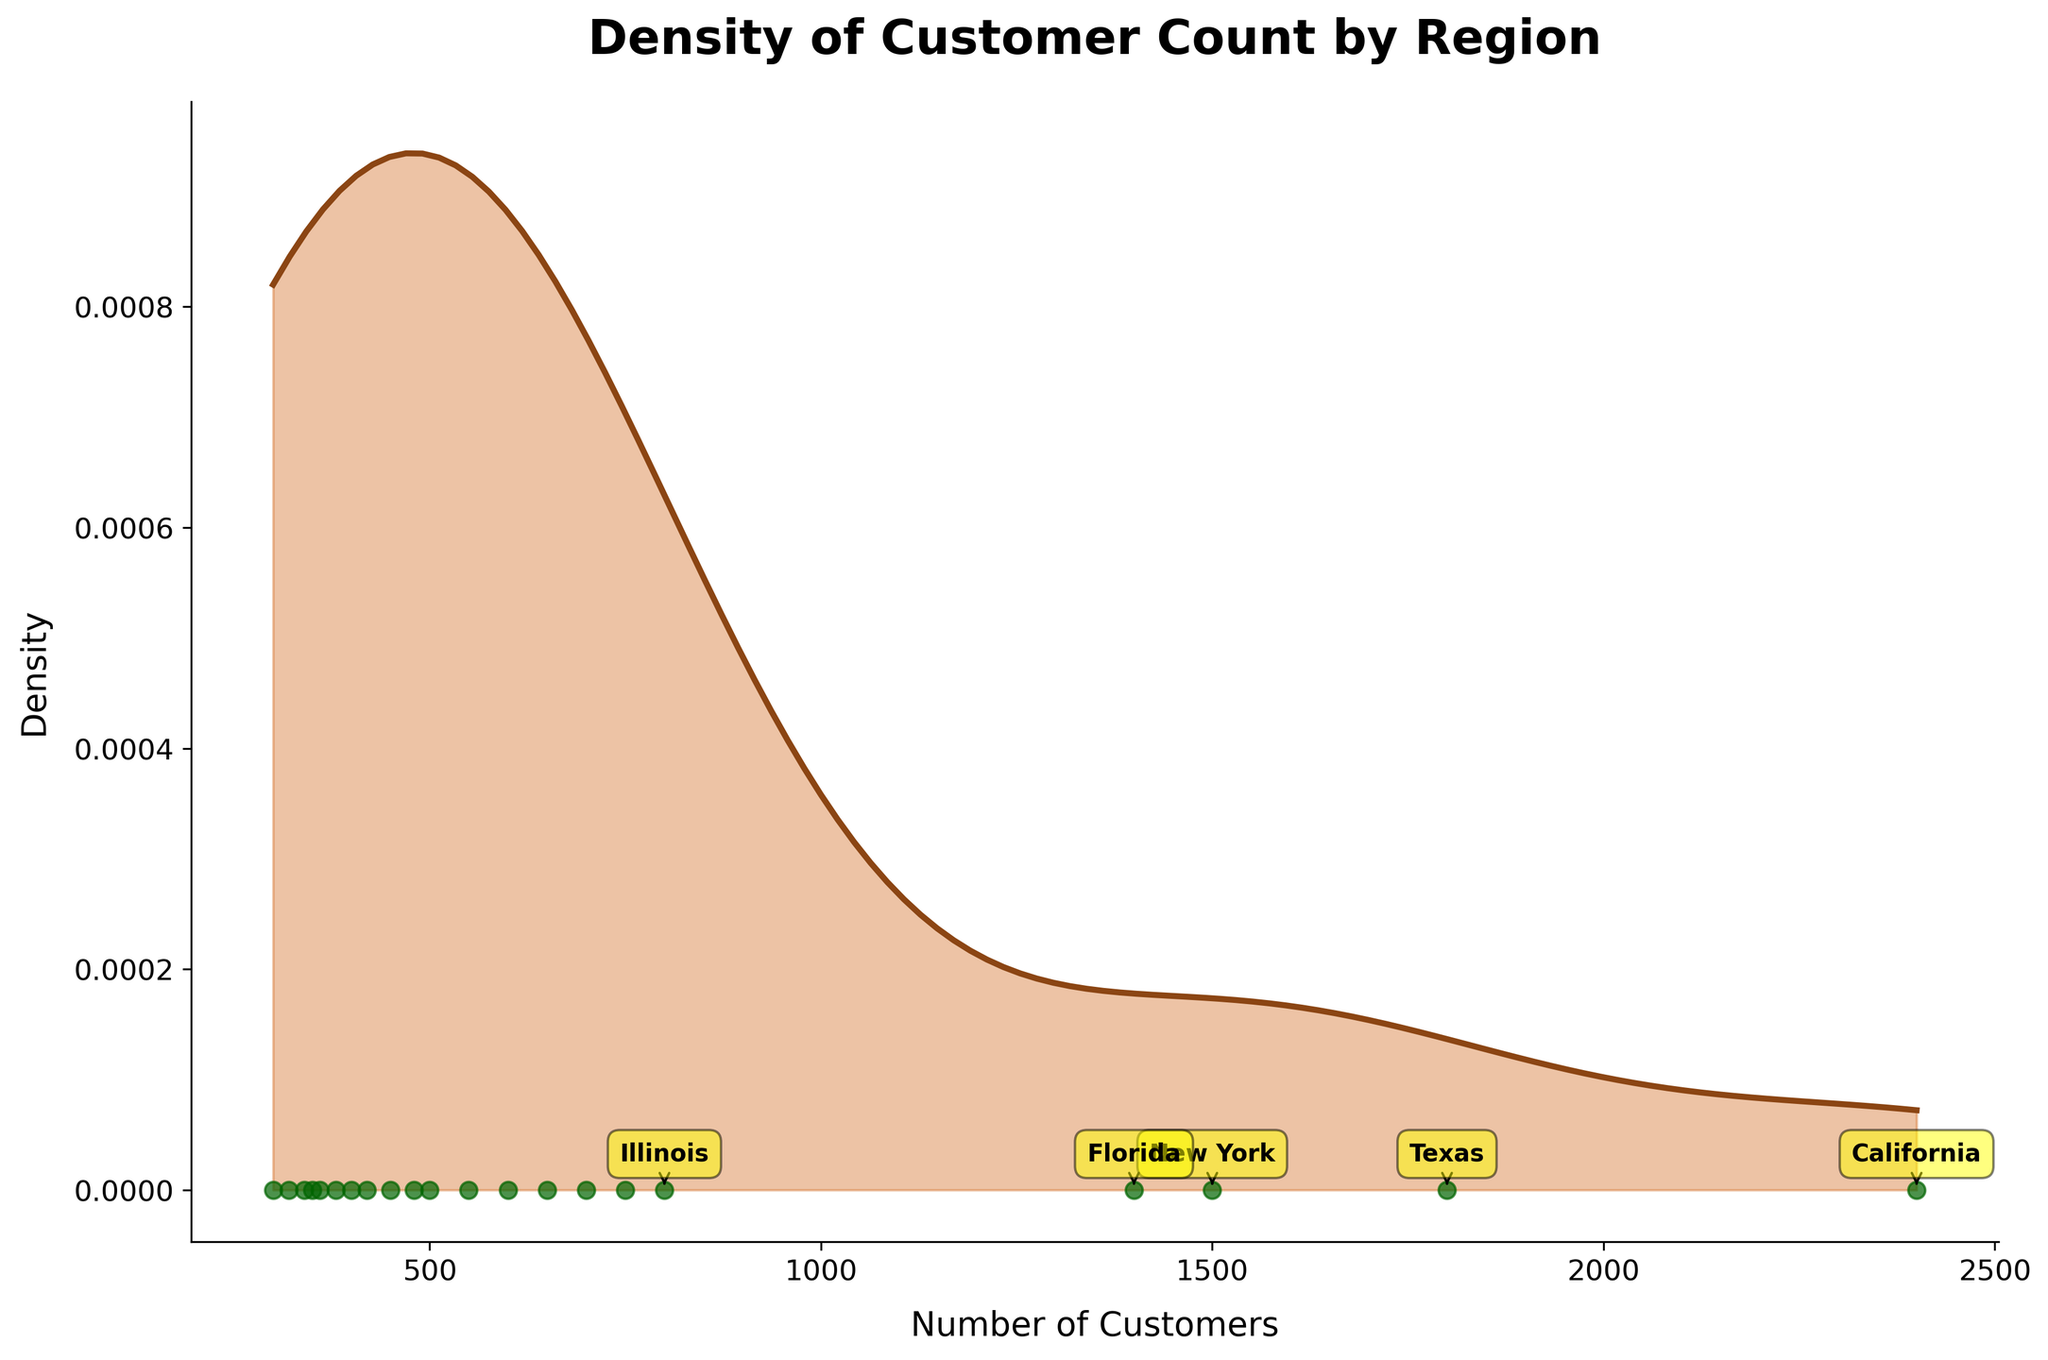What is the title of the figure? The title of the figure is visually the largest text, usually located at the top of the plot. In this figure, it reads "Density of Customer Count by Region."
Answer: Density of Customer Count by Region What color is used for the density line in the plot? The density line is represented using a continuous and prominently visible color to stand out. In this plot, it is drawn using a brownish color.
Answer: Brown Which region has the highest customer count? Looking at the annotations for the top 5 regions, the highest customer count is marked at the highest scatter point on the x-axis. The annotation for the highest peak is for the region "California."
Answer: California How many regions have been annotated in the figure? There are several written annotations pointing to specific points along the x-axis. By counting the distinct annotations, we see that the top 5 regions have been marked.
Answer: 5 What range of customer counts is covered in the x-axis? The x-axis ranges horizontally at the base of the plot. By observing the x-ticks, it starts from the minimum customer count found in Michigan (550 customers) to the maximum customer count found in California (2400 customers).
Answer: 300 to 2400 Which region has the lowest customer count amongst the top five regions? Comparing the top five annotated regions to their customer counts, Illinois has the smallest customer count among them.
Answer: Illinois How many states have customer counts above 1000? By observing the scatter points on the x-axis, those above the 1000 mark are counted. These correspond to California, Texas, New York, and Florida.
Answer: 4 What does the y-axis represent, and what is its significance? The y-axis is labeled "Density," and it indicates the estimate of the probability density function of the customer counts. It shows how customer counts are distributed across different regions, helping identify patterns or concentrations.
Answer: Density, represents probability density Between which two customer count values is the density the highest? The density line peaks at the highest point on the y-axis between two specific customer counts. Observing this peak, it can be seen it occurs around 0 on the x-axis where the largest concentration of customers lies, which is near the customer count for Texas and New York.
Answer: ~1800 and ~1500 Which regions have customer counts closest to the density peak? The density peak occurs near the scatter points representing customer counts close to the maximum density values. The regions closest to this peak are Texas and New York.
Answer: Texas and New York 